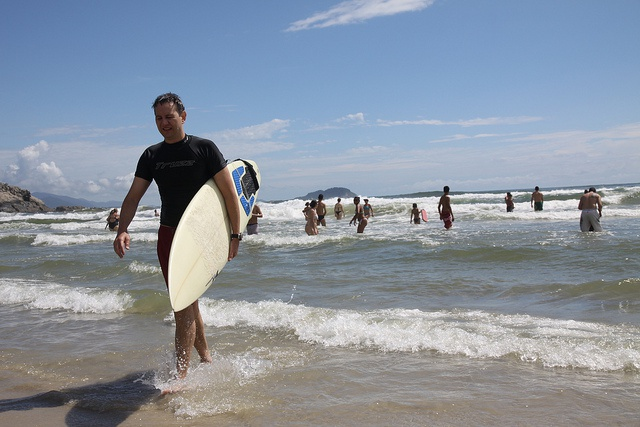Describe the objects in this image and their specific colors. I can see people in gray, black, and maroon tones, surfboard in gray, beige, and black tones, people in gray, darkgray, lightgray, and black tones, people in gray, black, and darkgray tones, and people in gray, black, maroon, and darkgray tones in this image. 